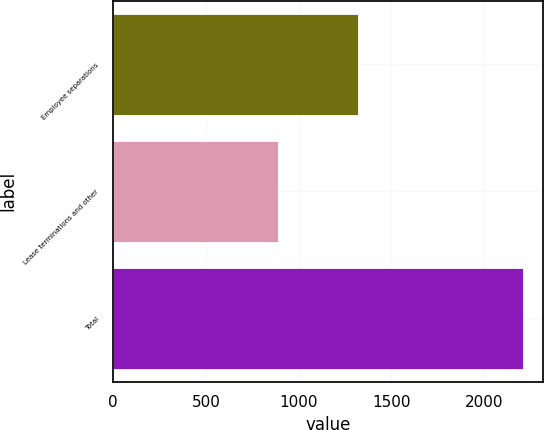Convert chart. <chart><loc_0><loc_0><loc_500><loc_500><bar_chart><fcel>Employee separations<fcel>Lease terminations and other<fcel>Total<nl><fcel>1319<fcel>890<fcel>2209<nl></chart> 